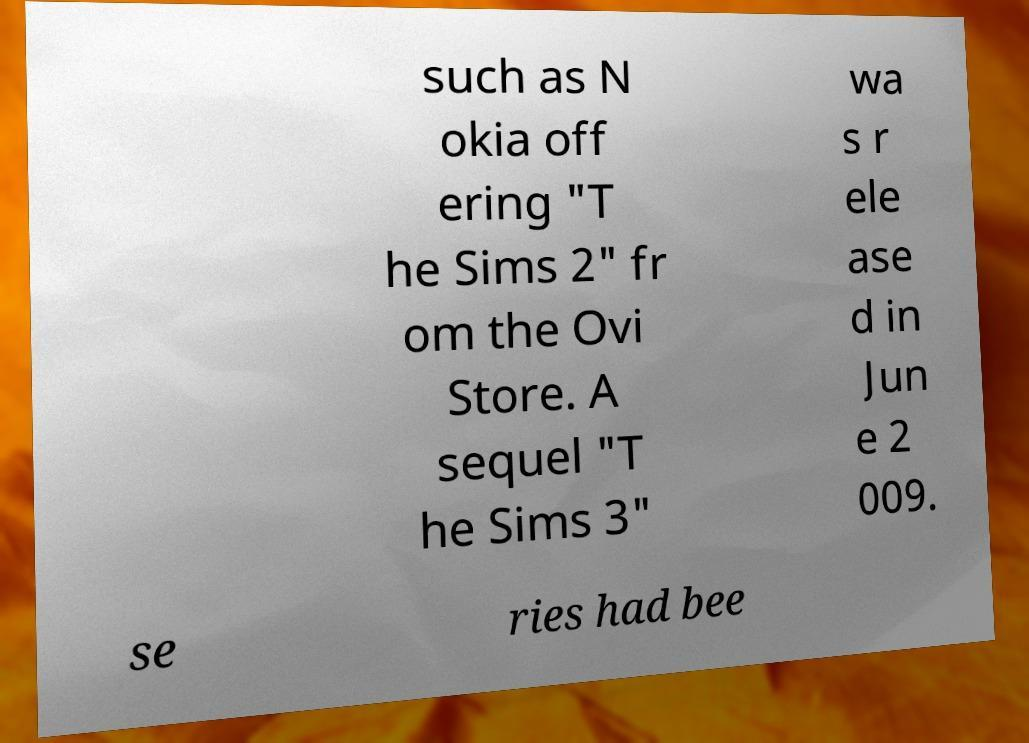There's text embedded in this image that I need extracted. Can you transcribe it verbatim? such as N okia off ering "T he Sims 2" fr om the Ovi Store. A sequel "T he Sims 3" wa s r ele ase d in Jun e 2 009. se ries had bee 